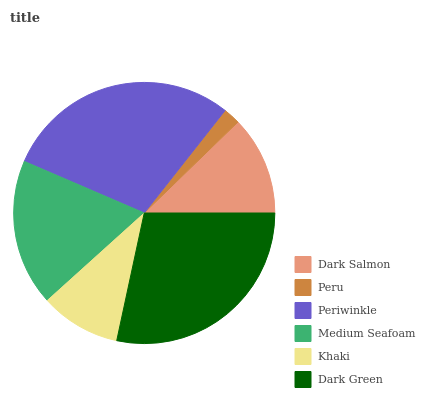Is Peru the minimum?
Answer yes or no. Yes. Is Periwinkle the maximum?
Answer yes or no. Yes. Is Periwinkle the minimum?
Answer yes or no. No. Is Peru the maximum?
Answer yes or no. No. Is Periwinkle greater than Peru?
Answer yes or no. Yes. Is Peru less than Periwinkle?
Answer yes or no. Yes. Is Peru greater than Periwinkle?
Answer yes or no. No. Is Periwinkle less than Peru?
Answer yes or no. No. Is Medium Seafoam the high median?
Answer yes or no. Yes. Is Dark Salmon the low median?
Answer yes or no. Yes. Is Dark Green the high median?
Answer yes or no. No. Is Dark Green the low median?
Answer yes or no. No. 